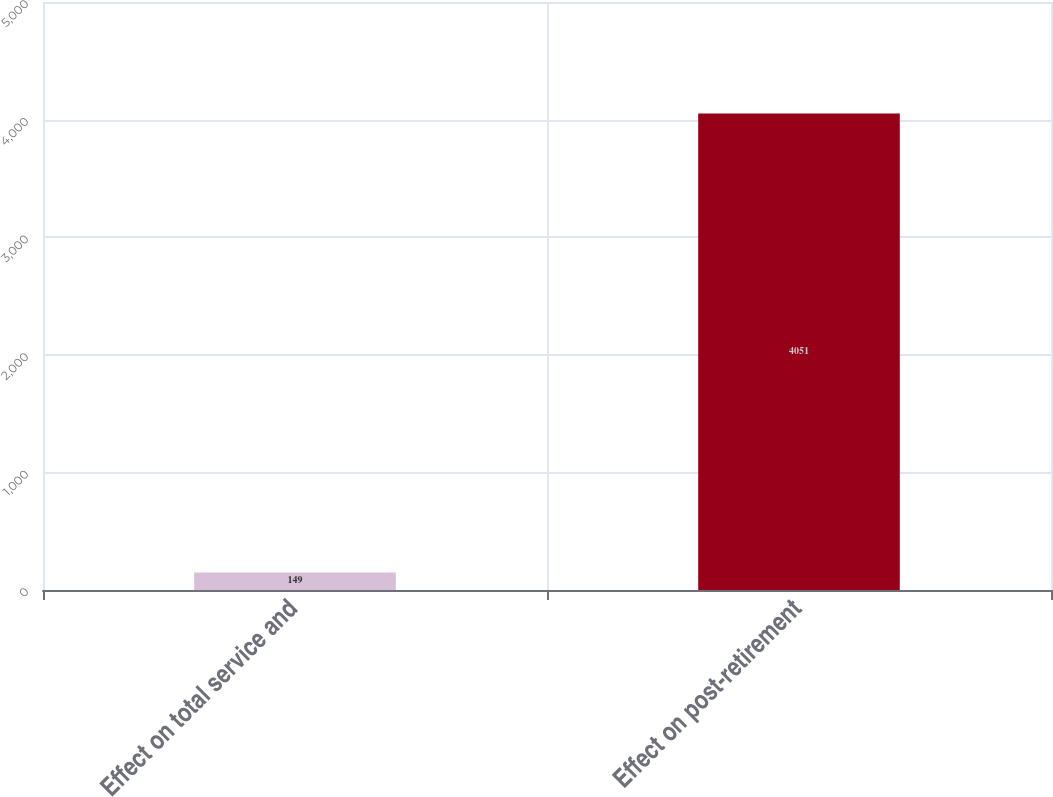<chart> <loc_0><loc_0><loc_500><loc_500><bar_chart><fcel>Effect on total service and<fcel>Effect on post-retirement<nl><fcel>149<fcel>4051<nl></chart> 